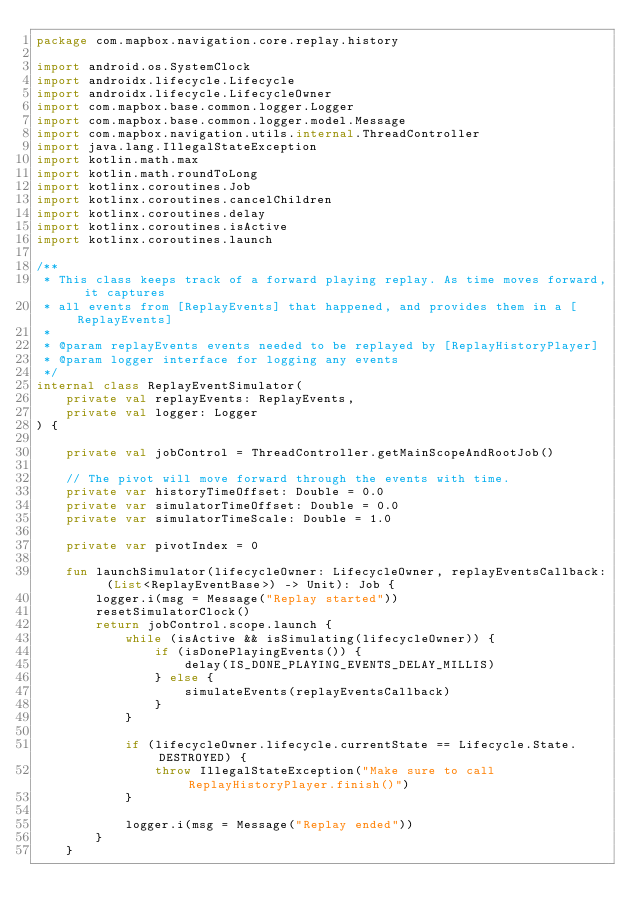Convert code to text. <code><loc_0><loc_0><loc_500><loc_500><_Kotlin_>package com.mapbox.navigation.core.replay.history

import android.os.SystemClock
import androidx.lifecycle.Lifecycle
import androidx.lifecycle.LifecycleOwner
import com.mapbox.base.common.logger.Logger
import com.mapbox.base.common.logger.model.Message
import com.mapbox.navigation.utils.internal.ThreadController
import java.lang.IllegalStateException
import kotlin.math.max
import kotlin.math.roundToLong
import kotlinx.coroutines.Job
import kotlinx.coroutines.cancelChildren
import kotlinx.coroutines.delay
import kotlinx.coroutines.isActive
import kotlinx.coroutines.launch

/**
 * This class keeps track of a forward playing replay. As time moves forward, it captures
 * all events from [ReplayEvents] that happened, and provides them in a [ReplayEvents]
 *
 * @param replayEvents events needed to be replayed by [ReplayHistoryPlayer]
 * @param logger interface for logging any events
 */
internal class ReplayEventSimulator(
    private val replayEvents: ReplayEvents,
    private val logger: Logger
) {

    private val jobControl = ThreadController.getMainScopeAndRootJob()

    // The pivot will move forward through the events with time.
    private var historyTimeOffset: Double = 0.0
    private var simulatorTimeOffset: Double = 0.0
    private var simulatorTimeScale: Double = 1.0

    private var pivotIndex = 0

    fun launchSimulator(lifecycleOwner: LifecycleOwner, replayEventsCallback: (List<ReplayEventBase>) -> Unit): Job {
        logger.i(msg = Message("Replay started"))
        resetSimulatorClock()
        return jobControl.scope.launch {
            while (isActive && isSimulating(lifecycleOwner)) {
                if (isDonePlayingEvents()) {
                    delay(IS_DONE_PLAYING_EVENTS_DELAY_MILLIS)
                } else {
                    simulateEvents(replayEventsCallback)
                }
            }

            if (lifecycleOwner.lifecycle.currentState == Lifecycle.State.DESTROYED) {
                throw IllegalStateException("Make sure to call ReplayHistoryPlayer.finish()")
            }

            logger.i(msg = Message("Replay ended"))
        }
    }
</code> 